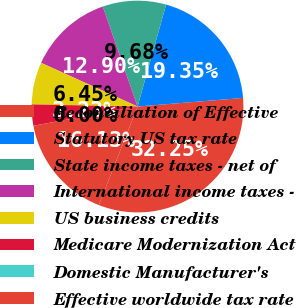Convert chart. <chart><loc_0><loc_0><loc_500><loc_500><pie_chart><fcel>Reconciliation of Effective<fcel>Statutory US tax rate<fcel>State income taxes - net of<fcel>International income taxes -<fcel>US business credits<fcel>Medicare Modernization Act<fcel>Domestic Manufacturer's<fcel>Effective worldwide tax rate<nl><fcel>32.25%<fcel>19.35%<fcel>9.68%<fcel>12.9%<fcel>6.45%<fcel>3.23%<fcel>0.0%<fcel>16.13%<nl></chart> 